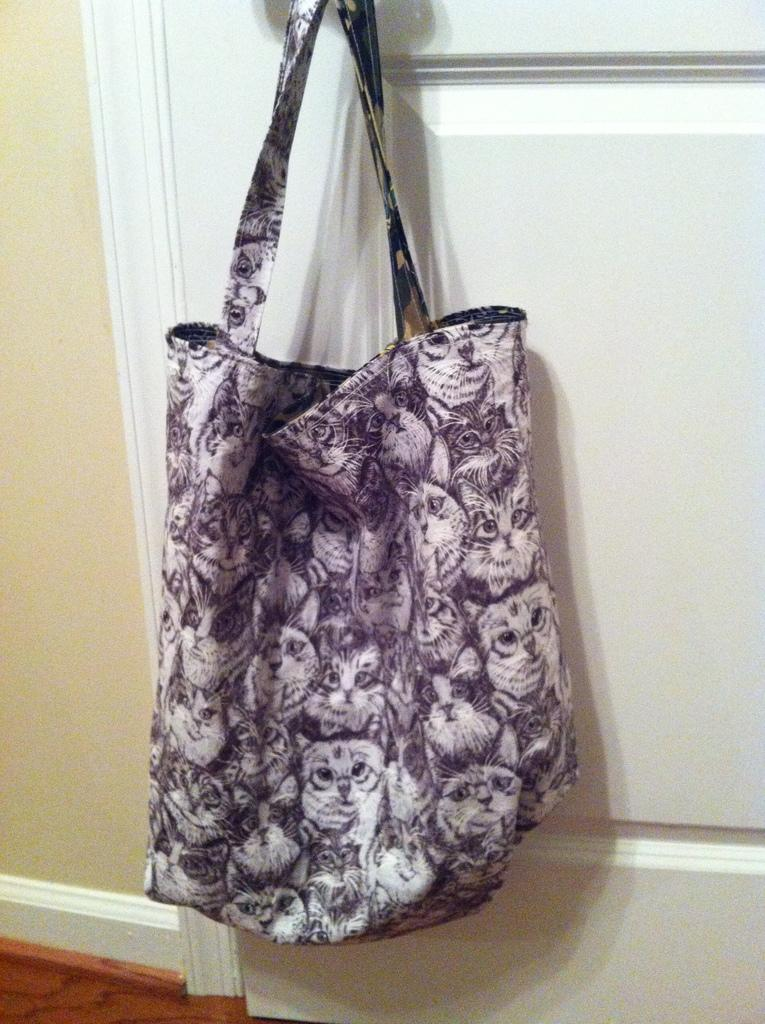What type of handbag is featured in the image? There is a purple and white cat printed handbag in the image. How is the handbag positioned in the image? The handbag is hanged on a door handle. What can be seen in the background of the image? There is a wall and a carpet in the background of the image. What type of muscle is visible in the image? There is no muscle visible in the image; it features a handbag hanging on a door handle. Can you tell me how many toothbrushes are in the image? There are no toothbrushes present in the image. 